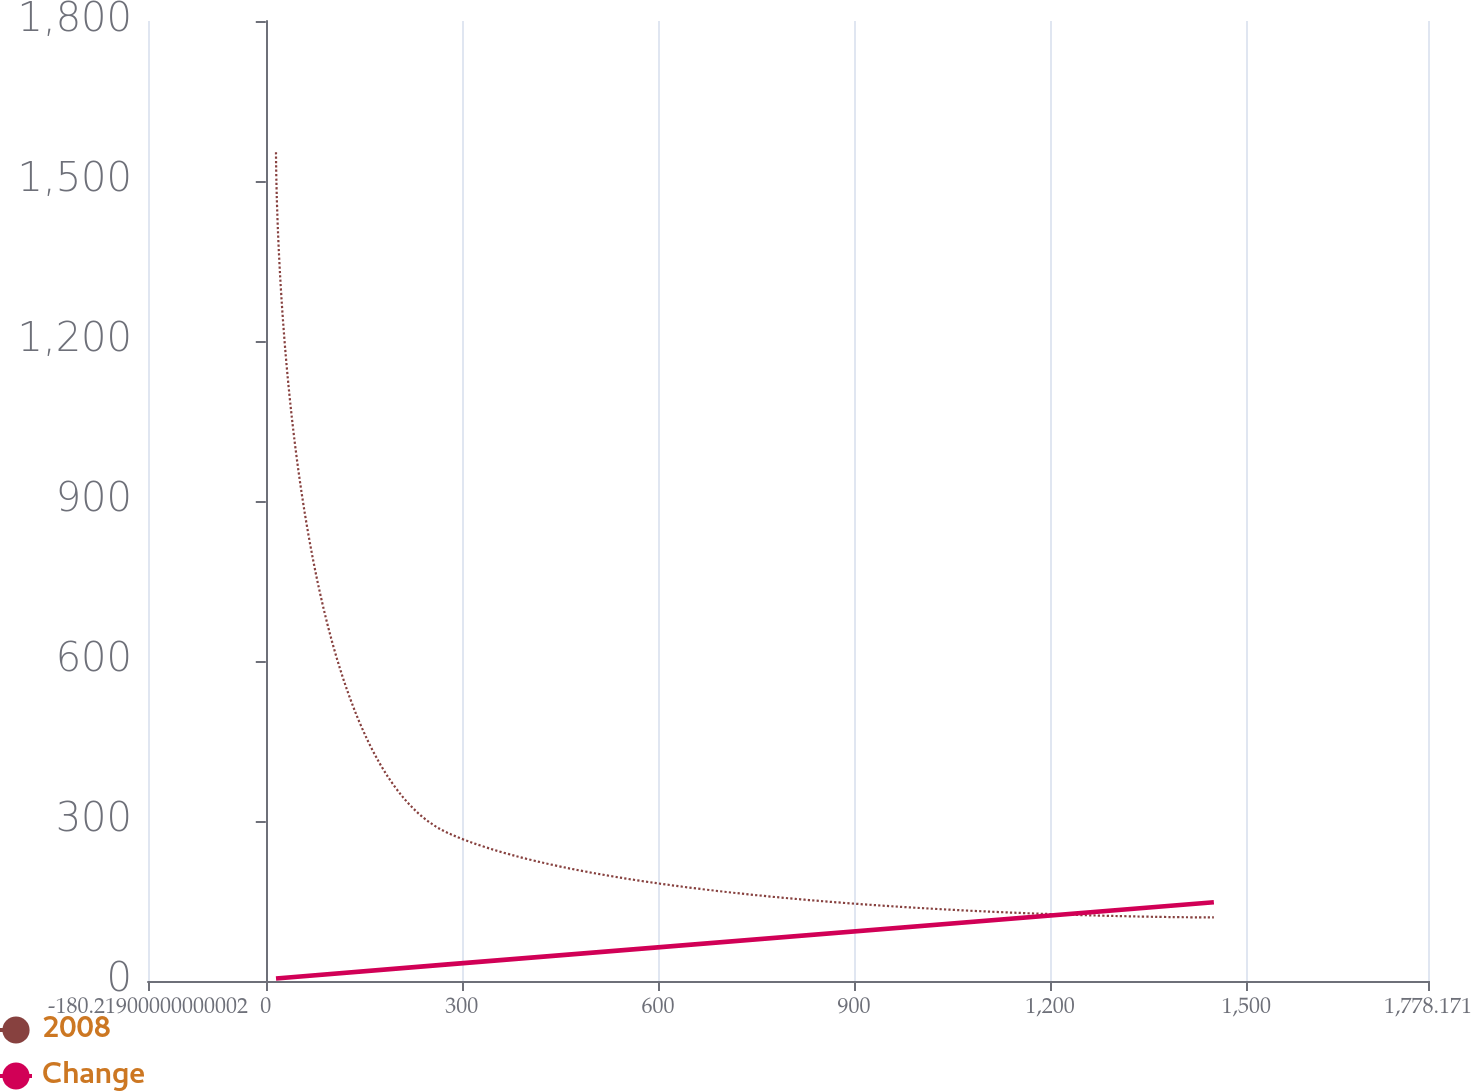Convert chart to OTSL. <chart><loc_0><loc_0><loc_500><loc_500><line_chart><ecel><fcel>2008<fcel>Change<nl><fcel>15.62<fcel>1553.91<fcel>4.68<nl><fcel>278.82<fcel>277.4<fcel>31.21<nl><fcel>1450.54<fcel>119.17<fcel>147.66<nl><fcel>1974.01<fcel>1711.28<fcel>173.06<nl></chart> 